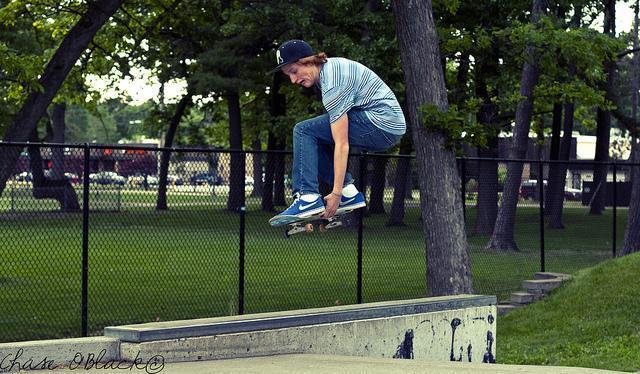How many wheels are on the truck on the right?
Give a very brief answer. 0. 